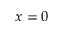<formula> <loc_0><loc_0><loc_500><loc_500>x = 0</formula> 